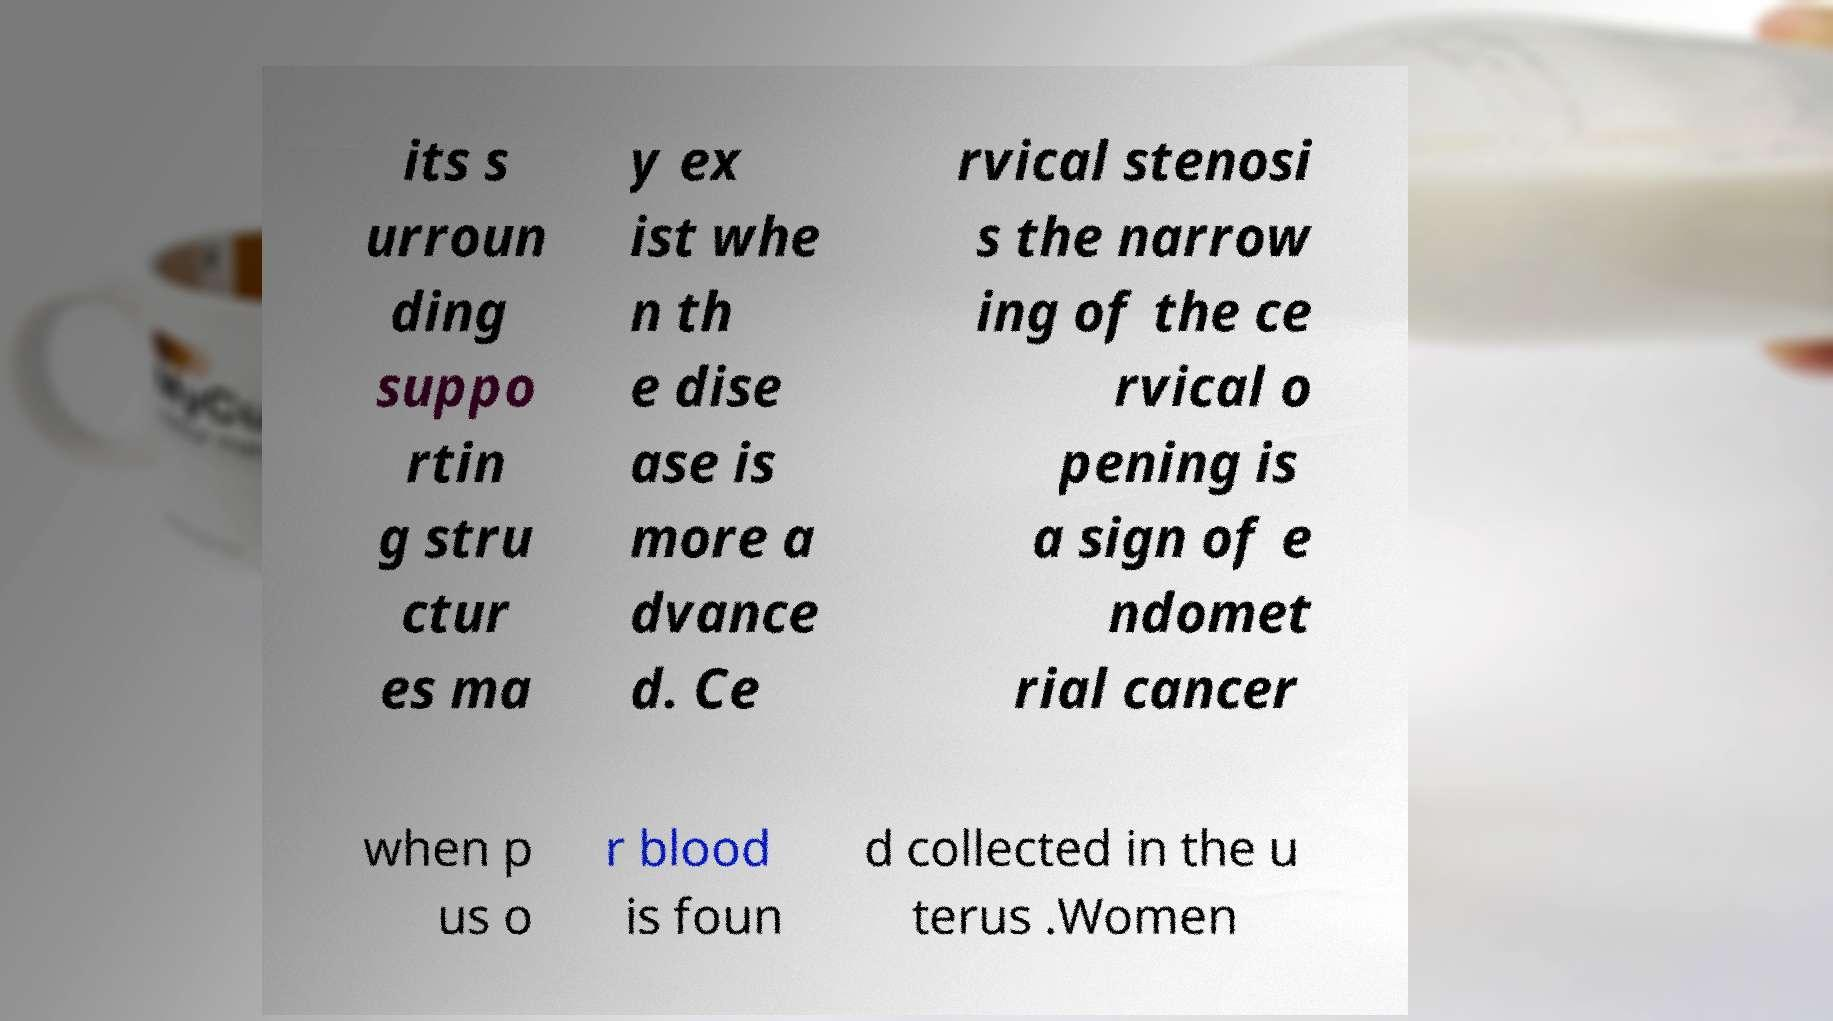Can you read and provide the text displayed in the image?This photo seems to have some interesting text. Can you extract and type it out for me? its s urroun ding suppo rtin g stru ctur es ma y ex ist whe n th e dise ase is more a dvance d. Ce rvical stenosi s the narrow ing of the ce rvical o pening is a sign of e ndomet rial cancer when p us o r blood is foun d collected in the u terus .Women 